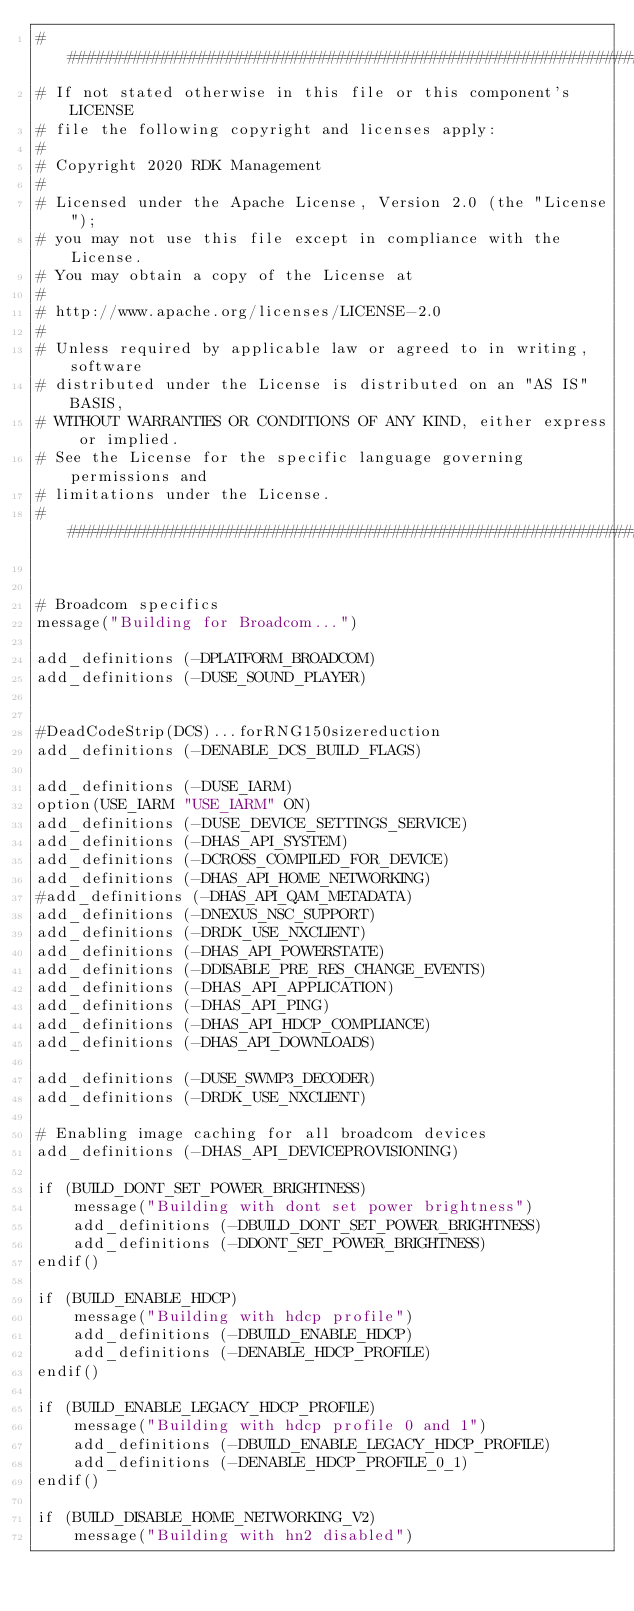<code> <loc_0><loc_0><loc_500><loc_500><_CMake_>##########################################################################
# If not stated otherwise in this file or this component's LICENSE
# file the following copyright and licenses apply:
#
# Copyright 2020 RDK Management
#
# Licensed under the Apache License, Version 2.0 (the "License");
# you may not use this file except in compliance with the License.
# You may obtain a copy of the License at
#
# http://www.apache.org/licenses/LICENSE-2.0
#
# Unless required by applicable law or agreed to in writing, software
# distributed under the License is distributed on an "AS IS" BASIS,
# WITHOUT WARRANTIES OR CONDITIONS OF ANY KIND, either express or implied.
# See the License for the specific language governing permissions and
# limitations under the License.
###########################################################################


# Broadcom specifics
message("Building for Broadcom...")

add_definitions (-DPLATFORM_BROADCOM)
add_definitions (-DUSE_SOUND_PLAYER)


#DeadCodeStrip(DCS)...forRNG150sizereduction
add_definitions (-DENABLE_DCS_BUILD_FLAGS)

add_definitions (-DUSE_IARM)
option(USE_IARM "USE_IARM" ON)
add_definitions (-DUSE_DEVICE_SETTINGS_SERVICE)
add_definitions (-DHAS_API_SYSTEM)
add_definitions (-DCROSS_COMPILED_FOR_DEVICE)
add_definitions (-DHAS_API_HOME_NETWORKING)
#add_definitions (-DHAS_API_QAM_METADATA)
add_definitions (-DNEXUS_NSC_SUPPORT)
add_definitions (-DRDK_USE_NXCLIENT)
add_definitions (-DHAS_API_POWERSTATE)
add_definitions (-DDISABLE_PRE_RES_CHANGE_EVENTS)
add_definitions (-DHAS_API_APPLICATION)
add_definitions (-DHAS_API_PING)
add_definitions (-DHAS_API_HDCP_COMPLIANCE)
add_definitions (-DHAS_API_DOWNLOADS)

add_definitions (-DUSE_SWMP3_DECODER)
add_definitions (-DRDK_USE_NXCLIENT)

# Enabling image caching for all broadcom devices
add_definitions (-DHAS_API_DEVICEPROVISIONING)

if (BUILD_DONT_SET_POWER_BRIGHTNESS)
    message("Building with dont set power brightness")
    add_definitions (-DBUILD_DONT_SET_POWER_BRIGHTNESS)
    add_definitions (-DDONT_SET_POWER_BRIGHTNESS)
endif()

if (BUILD_ENABLE_HDCP)
    message("Building with hdcp profile")
    add_definitions (-DBUILD_ENABLE_HDCP)
    add_definitions (-DENABLE_HDCP_PROFILE)
endif()

if (BUILD_ENABLE_LEGACY_HDCP_PROFILE)
    message("Building with hdcp profile 0 and 1")
    add_definitions (-DBUILD_ENABLE_LEGACY_HDCP_PROFILE)
    add_definitions (-DENABLE_HDCP_PROFILE_0_1)
endif()

if (BUILD_DISABLE_HOME_NETWORKING_V2)
    message("Building with hn2 disabled")</code> 